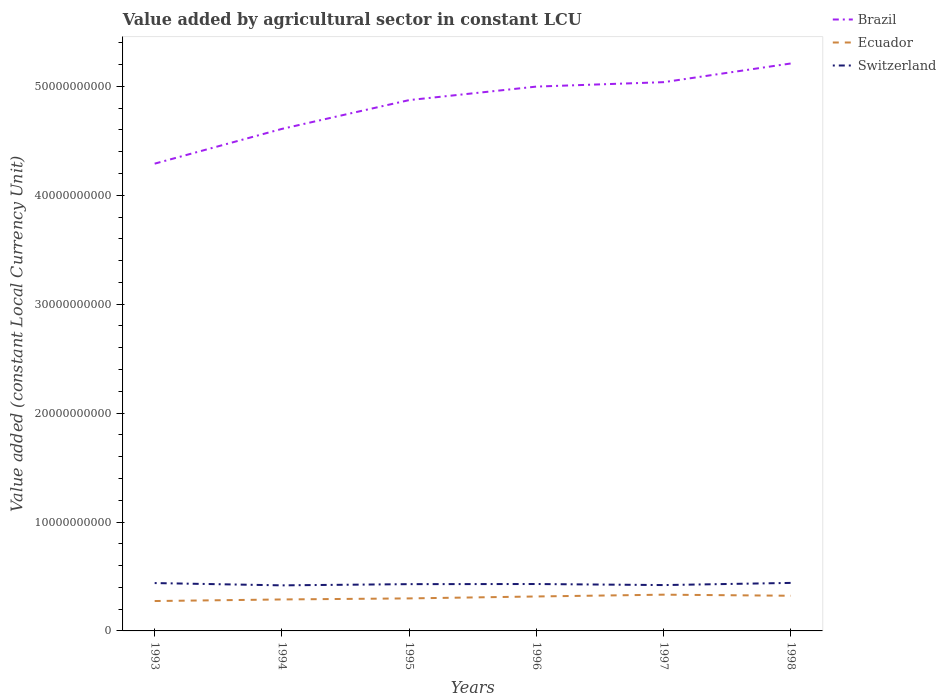How many different coloured lines are there?
Ensure brevity in your answer.  3. Across all years, what is the maximum value added by agricultural sector in Ecuador?
Provide a short and direct response. 2.74e+09. What is the total value added by agricultural sector in Brazil in the graph?
Your response must be concise. -4.06e+08. What is the difference between the highest and the second highest value added by agricultural sector in Ecuador?
Give a very brief answer. 5.84e+08. What is the difference between the highest and the lowest value added by agricultural sector in Brazil?
Offer a terse response. 4. How many years are there in the graph?
Your answer should be compact. 6. What is the difference between two consecutive major ticks on the Y-axis?
Keep it short and to the point. 1.00e+1. Are the values on the major ticks of Y-axis written in scientific E-notation?
Keep it short and to the point. No. Does the graph contain any zero values?
Ensure brevity in your answer.  No. Does the graph contain grids?
Give a very brief answer. No. Where does the legend appear in the graph?
Offer a terse response. Top right. What is the title of the graph?
Offer a terse response. Value added by agricultural sector in constant LCU. Does "Estonia" appear as one of the legend labels in the graph?
Your response must be concise. No. What is the label or title of the X-axis?
Your answer should be compact. Years. What is the label or title of the Y-axis?
Keep it short and to the point. Value added (constant Local Currency Unit). What is the Value added (constant Local Currency Unit) in Brazil in 1993?
Make the answer very short. 4.29e+1. What is the Value added (constant Local Currency Unit) of Ecuador in 1993?
Your response must be concise. 2.74e+09. What is the Value added (constant Local Currency Unit) in Switzerland in 1993?
Give a very brief answer. 4.39e+09. What is the Value added (constant Local Currency Unit) in Brazil in 1994?
Keep it short and to the point. 4.61e+1. What is the Value added (constant Local Currency Unit) of Ecuador in 1994?
Provide a succinct answer. 2.89e+09. What is the Value added (constant Local Currency Unit) in Switzerland in 1994?
Offer a very short reply. 4.18e+09. What is the Value added (constant Local Currency Unit) of Brazil in 1995?
Keep it short and to the point. 4.87e+1. What is the Value added (constant Local Currency Unit) of Ecuador in 1995?
Your answer should be very brief. 2.99e+09. What is the Value added (constant Local Currency Unit) in Switzerland in 1995?
Offer a very short reply. 4.29e+09. What is the Value added (constant Local Currency Unit) of Brazil in 1996?
Offer a very short reply. 5.00e+1. What is the Value added (constant Local Currency Unit) of Ecuador in 1996?
Keep it short and to the point. 3.16e+09. What is the Value added (constant Local Currency Unit) of Switzerland in 1996?
Provide a short and direct response. 4.31e+09. What is the Value added (constant Local Currency Unit) of Brazil in 1997?
Keep it short and to the point. 5.04e+1. What is the Value added (constant Local Currency Unit) of Ecuador in 1997?
Your answer should be very brief. 3.33e+09. What is the Value added (constant Local Currency Unit) of Switzerland in 1997?
Make the answer very short. 4.21e+09. What is the Value added (constant Local Currency Unit) of Brazil in 1998?
Your answer should be very brief. 5.21e+1. What is the Value added (constant Local Currency Unit) of Ecuador in 1998?
Offer a terse response. 3.23e+09. What is the Value added (constant Local Currency Unit) of Switzerland in 1998?
Offer a very short reply. 4.41e+09. Across all years, what is the maximum Value added (constant Local Currency Unit) of Brazil?
Offer a very short reply. 5.21e+1. Across all years, what is the maximum Value added (constant Local Currency Unit) in Ecuador?
Ensure brevity in your answer.  3.33e+09. Across all years, what is the maximum Value added (constant Local Currency Unit) of Switzerland?
Ensure brevity in your answer.  4.41e+09. Across all years, what is the minimum Value added (constant Local Currency Unit) in Brazil?
Keep it short and to the point. 4.29e+1. Across all years, what is the minimum Value added (constant Local Currency Unit) in Ecuador?
Your response must be concise. 2.74e+09. Across all years, what is the minimum Value added (constant Local Currency Unit) in Switzerland?
Your answer should be very brief. 4.18e+09. What is the total Value added (constant Local Currency Unit) in Brazil in the graph?
Provide a succinct answer. 2.90e+11. What is the total Value added (constant Local Currency Unit) in Ecuador in the graph?
Offer a very short reply. 1.83e+1. What is the total Value added (constant Local Currency Unit) in Switzerland in the graph?
Offer a very short reply. 2.58e+1. What is the difference between the Value added (constant Local Currency Unit) of Brazil in 1993 and that in 1994?
Offer a very short reply. -3.19e+09. What is the difference between the Value added (constant Local Currency Unit) of Ecuador in 1993 and that in 1994?
Give a very brief answer. -1.45e+08. What is the difference between the Value added (constant Local Currency Unit) of Switzerland in 1993 and that in 1994?
Make the answer very short. 2.11e+08. What is the difference between the Value added (constant Local Currency Unit) of Brazil in 1993 and that in 1995?
Provide a succinct answer. -5.84e+09. What is the difference between the Value added (constant Local Currency Unit) of Ecuador in 1993 and that in 1995?
Make the answer very short. -2.42e+08. What is the difference between the Value added (constant Local Currency Unit) in Switzerland in 1993 and that in 1995?
Provide a succinct answer. 9.94e+07. What is the difference between the Value added (constant Local Currency Unit) of Brazil in 1993 and that in 1996?
Provide a short and direct response. -7.08e+09. What is the difference between the Value added (constant Local Currency Unit) in Ecuador in 1993 and that in 1996?
Keep it short and to the point. -4.19e+08. What is the difference between the Value added (constant Local Currency Unit) of Switzerland in 1993 and that in 1996?
Provide a succinct answer. 8.82e+07. What is the difference between the Value added (constant Local Currency Unit) of Brazil in 1993 and that in 1997?
Offer a very short reply. -7.48e+09. What is the difference between the Value added (constant Local Currency Unit) in Ecuador in 1993 and that in 1997?
Offer a terse response. -5.84e+08. What is the difference between the Value added (constant Local Currency Unit) in Switzerland in 1993 and that in 1997?
Offer a very short reply. 1.85e+08. What is the difference between the Value added (constant Local Currency Unit) of Brazil in 1993 and that in 1998?
Your response must be concise. -9.20e+09. What is the difference between the Value added (constant Local Currency Unit) of Ecuador in 1993 and that in 1998?
Your answer should be compact. -4.85e+08. What is the difference between the Value added (constant Local Currency Unit) of Switzerland in 1993 and that in 1998?
Your answer should be very brief. -1.39e+07. What is the difference between the Value added (constant Local Currency Unit) of Brazil in 1994 and that in 1995?
Provide a short and direct response. -2.64e+09. What is the difference between the Value added (constant Local Currency Unit) of Ecuador in 1994 and that in 1995?
Make the answer very short. -9.67e+07. What is the difference between the Value added (constant Local Currency Unit) in Switzerland in 1994 and that in 1995?
Your response must be concise. -1.11e+08. What is the difference between the Value added (constant Local Currency Unit) of Brazil in 1994 and that in 1996?
Offer a very short reply. -3.88e+09. What is the difference between the Value added (constant Local Currency Unit) of Ecuador in 1994 and that in 1996?
Your response must be concise. -2.74e+08. What is the difference between the Value added (constant Local Currency Unit) in Switzerland in 1994 and that in 1996?
Offer a very short reply. -1.23e+08. What is the difference between the Value added (constant Local Currency Unit) of Brazil in 1994 and that in 1997?
Make the answer very short. -4.29e+09. What is the difference between the Value added (constant Local Currency Unit) in Ecuador in 1994 and that in 1997?
Keep it short and to the point. -4.39e+08. What is the difference between the Value added (constant Local Currency Unit) of Switzerland in 1994 and that in 1997?
Provide a succinct answer. -2.58e+07. What is the difference between the Value added (constant Local Currency Unit) in Brazil in 1994 and that in 1998?
Provide a short and direct response. -6.01e+09. What is the difference between the Value added (constant Local Currency Unit) of Ecuador in 1994 and that in 1998?
Provide a short and direct response. -3.40e+08. What is the difference between the Value added (constant Local Currency Unit) in Switzerland in 1994 and that in 1998?
Your answer should be very brief. -2.25e+08. What is the difference between the Value added (constant Local Currency Unit) of Brazil in 1995 and that in 1996?
Your response must be concise. -1.24e+09. What is the difference between the Value added (constant Local Currency Unit) in Ecuador in 1995 and that in 1996?
Provide a short and direct response. -1.77e+08. What is the difference between the Value added (constant Local Currency Unit) in Switzerland in 1995 and that in 1996?
Your response must be concise. -1.12e+07. What is the difference between the Value added (constant Local Currency Unit) of Brazil in 1995 and that in 1997?
Keep it short and to the point. -1.65e+09. What is the difference between the Value added (constant Local Currency Unit) in Ecuador in 1995 and that in 1997?
Provide a succinct answer. -3.42e+08. What is the difference between the Value added (constant Local Currency Unit) in Switzerland in 1995 and that in 1997?
Your answer should be compact. 8.56e+07. What is the difference between the Value added (constant Local Currency Unit) of Brazil in 1995 and that in 1998?
Offer a terse response. -3.36e+09. What is the difference between the Value added (constant Local Currency Unit) in Ecuador in 1995 and that in 1998?
Ensure brevity in your answer.  -2.43e+08. What is the difference between the Value added (constant Local Currency Unit) in Switzerland in 1995 and that in 1998?
Your answer should be very brief. -1.13e+08. What is the difference between the Value added (constant Local Currency Unit) in Brazil in 1996 and that in 1997?
Provide a succinct answer. -4.06e+08. What is the difference between the Value added (constant Local Currency Unit) in Ecuador in 1996 and that in 1997?
Offer a very short reply. -1.65e+08. What is the difference between the Value added (constant Local Currency Unit) of Switzerland in 1996 and that in 1997?
Your answer should be compact. 9.68e+07. What is the difference between the Value added (constant Local Currency Unit) of Brazil in 1996 and that in 1998?
Your response must be concise. -2.12e+09. What is the difference between the Value added (constant Local Currency Unit) in Ecuador in 1996 and that in 1998?
Provide a succinct answer. -6.60e+07. What is the difference between the Value added (constant Local Currency Unit) in Switzerland in 1996 and that in 1998?
Make the answer very short. -1.02e+08. What is the difference between the Value added (constant Local Currency Unit) in Brazil in 1997 and that in 1998?
Keep it short and to the point. -1.72e+09. What is the difference between the Value added (constant Local Currency Unit) in Ecuador in 1997 and that in 1998?
Your response must be concise. 9.92e+07. What is the difference between the Value added (constant Local Currency Unit) of Switzerland in 1997 and that in 1998?
Ensure brevity in your answer.  -1.99e+08. What is the difference between the Value added (constant Local Currency Unit) in Brazil in 1993 and the Value added (constant Local Currency Unit) in Ecuador in 1994?
Make the answer very short. 4.00e+1. What is the difference between the Value added (constant Local Currency Unit) in Brazil in 1993 and the Value added (constant Local Currency Unit) in Switzerland in 1994?
Your answer should be very brief. 3.87e+1. What is the difference between the Value added (constant Local Currency Unit) of Ecuador in 1993 and the Value added (constant Local Currency Unit) of Switzerland in 1994?
Give a very brief answer. -1.44e+09. What is the difference between the Value added (constant Local Currency Unit) in Brazil in 1993 and the Value added (constant Local Currency Unit) in Ecuador in 1995?
Provide a succinct answer. 3.99e+1. What is the difference between the Value added (constant Local Currency Unit) in Brazil in 1993 and the Value added (constant Local Currency Unit) in Switzerland in 1995?
Your answer should be very brief. 3.86e+1. What is the difference between the Value added (constant Local Currency Unit) of Ecuador in 1993 and the Value added (constant Local Currency Unit) of Switzerland in 1995?
Give a very brief answer. -1.55e+09. What is the difference between the Value added (constant Local Currency Unit) in Brazil in 1993 and the Value added (constant Local Currency Unit) in Ecuador in 1996?
Offer a terse response. 3.97e+1. What is the difference between the Value added (constant Local Currency Unit) of Brazil in 1993 and the Value added (constant Local Currency Unit) of Switzerland in 1996?
Your response must be concise. 3.86e+1. What is the difference between the Value added (constant Local Currency Unit) in Ecuador in 1993 and the Value added (constant Local Currency Unit) in Switzerland in 1996?
Your answer should be compact. -1.56e+09. What is the difference between the Value added (constant Local Currency Unit) in Brazil in 1993 and the Value added (constant Local Currency Unit) in Ecuador in 1997?
Offer a terse response. 3.96e+1. What is the difference between the Value added (constant Local Currency Unit) of Brazil in 1993 and the Value added (constant Local Currency Unit) of Switzerland in 1997?
Ensure brevity in your answer.  3.87e+1. What is the difference between the Value added (constant Local Currency Unit) of Ecuador in 1993 and the Value added (constant Local Currency Unit) of Switzerland in 1997?
Give a very brief answer. -1.47e+09. What is the difference between the Value added (constant Local Currency Unit) in Brazil in 1993 and the Value added (constant Local Currency Unit) in Ecuador in 1998?
Your response must be concise. 3.97e+1. What is the difference between the Value added (constant Local Currency Unit) in Brazil in 1993 and the Value added (constant Local Currency Unit) in Switzerland in 1998?
Your response must be concise. 3.85e+1. What is the difference between the Value added (constant Local Currency Unit) of Ecuador in 1993 and the Value added (constant Local Currency Unit) of Switzerland in 1998?
Offer a very short reply. -1.66e+09. What is the difference between the Value added (constant Local Currency Unit) in Brazil in 1994 and the Value added (constant Local Currency Unit) in Ecuador in 1995?
Keep it short and to the point. 4.31e+1. What is the difference between the Value added (constant Local Currency Unit) in Brazil in 1994 and the Value added (constant Local Currency Unit) in Switzerland in 1995?
Provide a short and direct response. 4.18e+1. What is the difference between the Value added (constant Local Currency Unit) in Ecuador in 1994 and the Value added (constant Local Currency Unit) in Switzerland in 1995?
Ensure brevity in your answer.  -1.41e+09. What is the difference between the Value added (constant Local Currency Unit) of Brazil in 1994 and the Value added (constant Local Currency Unit) of Ecuador in 1996?
Ensure brevity in your answer.  4.29e+1. What is the difference between the Value added (constant Local Currency Unit) of Brazil in 1994 and the Value added (constant Local Currency Unit) of Switzerland in 1996?
Make the answer very short. 4.18e+1. What is the difference between the Value added (constant Local Currency Unit) of Ecuador in 1994 and the Value added (constant Local Currency Unit) of Switzerland in 1996?
Your answer should be very brief. -1.42e+09. What is the difference between the Value added (constant Local Currency Unit) of Brazil in 1994 and the Value added (constant Local Currency Unit) of Ecuador in 1997?
Offer a terse response. 4.28e+1. What is the difference between the Value added (constant Local Currency Unit) in Brazil in 1994 and the Value added (constant Local Currency Unit) in Switzerland in 1997?
Your response must be concise. 4.19e+1. What is the difference between the Value added (constant Local Currency Unit) of Ecuador in 1994 and the Value added (constant Local Currency Unit) of Switzerland in 1997?
Make the answer very short. -1.32e+09. What is the difference between the Value added (constant Local Currency Unit) in Brazil in 1994 and the Value added (constant Local Currency Unit) in Ecuador in 1998?
Your answer should be very brief. 4.29e+1. What is the difference between the Value added (constant Local Currency Unit) of Brazil in 1994 and the Value added (constant Local Currency Unit) of Switzerland in 1998?
Your answer should be very brief. 4.17e+1. What is the difference between the Value added (constant Local Currency Unit) of Ecuador in 1994 and the Value added (constant Local Currency Unit) of Switzerland in 1998?
Your response must be concise. -1.52e+09. What is the difference between the Value added (constant Local Currency Unit) in Brazil in 1995 and the Value added (constant Local Currency Unit) in Ecuador in 1996?
Offer a very short reply. 4.56e+1. What is the difference between the Value added (constant Local Currency Unit) of Brazil in 1995 and the Value added (constant Local Currency Unit) of Switzerland in 1996?
Provide a succinct answer. 4.44e+1. What is the difference between the Value added (constant Local Currency Unit) in Ecuador in 1995 and the Value added (constant Local Currency Unit) in Switzerland in 1996?
Provide a short and direct response. -1.32e+09. What is the difference between the Value added (constant Local Currency Unit) in Brazil in 1995 and the Value added (constant Local Currency Unit) in Ecuador in 1997?
Provide a succinct answer. 4.54e+1. What is the difference between the Value added (constant Local Currency Unit) of Brazil in 1995 and the Value added (constant Local Currency Unit) of Switzerland in 1997?
Provide a succinct answer. 4.45e+1. What is the difference between the Value added (constant Local Currency Unit) of Ecuador in 1995 and the Value added (constant Local Currency Unit) of Switzerland in 1997?
Your answer should be compact. -1.22e+09. What is the difference between the Value added (constant Local Currency Unit) in Brazil in 1995 and the Value added (constant Local Currency Unit) in Ecuador in 1998?
Keep it short and to the point. 4.55e+1. What is the difference between the Value added (constant Local Currency Unit) in Brazil in 1995 and the Value added (constant Local Currency Unit) in Switzerland in 1998?
Give a very brief answer. 4.43e+1. What is the difference between the Value added (constant Local Currency Unit) in Ecuador in 1995 and the Value added (constant Local Currency Unit) in Switzerland in 1998?
Your answer should be compact. -1.42e+09. What is the difference between the Value added (constant Local Currency Unit) of Brazil in 1996 and the Value added (constant Local Currency Unit) of Ecuador in 1997?
Provide a short and direct response. 4.66e+1. What is the difference between the Value added (constant Local Currency Unit) of Brazil in 1996 and the Value added (constant Local Currency Unit) of Switzerland in 1997?
Make the answer very short. 4.58e+1. What is the difference between the Value added (constant Local Currency Unit) in Ecuador in 1996 and the Value added (constant Local Currency Unit) in Switzerland in 1997?
Provide a succinct answer. -1.05e+09. What is the difference between the Value added (constant Local Currency Unit) of Brazil in 1996 and the Value added (constant Local Currency Unit) of Ecuador in 1998?
Keep it short and to the point. 4.67e+1. What is the difference between the Value added (constant Local Currency Unit) of Brazil in 1996 and the Value added (constant Local Currency Unit) of Switzerland in 1998?
Make the answer very short. 4.56e+1. What is the difference between the Value added (constant Local Currency Unit) of Ecuador in 1996 and the Value added (constant Local Currency Unit) of Switzerland in 1998?
Ensure brevity in your answer.  -1.25e+09. What is the difference between the Value added (constant Local Currency Unit) in Brazil in 1997 and the Value added (constant Local Currency Unit) in Ecuador in 1998?
Offer a terse response. 4.72e+1. What is the difference between the Value added (constant Local Currency Unit) in Brazil in 1997 and the Value added (constant Local Currency Unit) in Switzerland in 1998?
Your response must be concise. 4.60e+1. What is the difference between the Value added (constant Local Currency Unit) of Ecuador in 1997 and the Value added (constant Local Currency Unit) of Switzerland in 1998?
Provide a short and direct response. -1.08e+09. What is the average Value added (constant Local Currency Unit) of Brazil per year?
Provide a succinct answer. 4.84e+1. What is the average Value added (constant Local Currency Unit) in Ecuador per year?
Ensure brevity in your answer.  3.06e+09. What is the average Value added (constant Local Currency Unit) of Switzerland per year?
Ensure brevity in your answer.  4.30e+09. In the year 1993, what is the difference between the Value added (constant Local Currency Unit) of Brazil and Value added (constant Local Currency Unit) of Ecuador?
Ensure brevity in your answer.  4.02e+1. In the year 1993, what is the difference between the Value added (constant Local Currency Unit) in Brazil and Value added (constant Local Currency Unit) in Switzerland?
Provide a succinct answer. 3.85e+1. In the year 1993, what is the difference between the Value added (constant Local Currency Unit) in Ecuador and Value added (constant Local Currency Unit) in Switzerland?
Your answer should be very brief. -1.65e+09. In the year 1994, what is the difference between the Value added (constant Local Currency Unit) of Brazil and Value added (constant Local Currency Unit) of Ecuador?
Your answer should be very brief. 4.32e+1. In the year 1994, what is the difference between the Value added (constant Local Currency Unit) in Brazil and Value added (constant Local Currency Unit) in Switzerland?
Offer a very short reply. 4.19e+1. In the year 1994, what is the difference between the Value added (constant Local Currency Unit) of Ecuador and Value added (constant Local Currency Unit) of Switzerland?
Your answer should be very brief. -1.29e+09. In the year 1995, what is the difference between the Value added (constant Local Currency Unit) in Brazil and Value added (constant Local Currency Unit) in Ecuador?
Your answer should be compact. 4.58e+1. In the year 1995, what is the difference between the Value added (constant Local Currency Unit) of Brazil and Value added (constant Local Currency Unit) of Switzerland?
Offer a very short reply. 4.44e+1. In the year 1995, what is the difference between the Value added (constant Local Currency Unit) of Ecuador and Value added (constant Local Currency Unit) of Switzerland?
Offer a very short reply. -1.31e+09. In the year 1996, what is the difference between the Value added (constant Local Currency Unit) of Brazil and Value added (constant Local Currency Unit) of Ecuador?
Make the answer very short. 4.68e+1. In the year 1996, what is the difference between the Value added (constant Local Currency Unit) in Brazil and Value added (constant Local Currency Unit) in Switzerland?
Keep it short and to the point. 4.57e+1. In the year 1996, what is the difference between the Value added (constant Local Currency Unit) in Ecuador and Value added (constant Local Currency Unit) in Switzerland?
Provide a succinct answer. -1.14e+09. In the year 1997, what is the difference between the Value added (constant Local Currency Unit) in Brazil and Value added (constant Local Currency Unit) in Ecuador?
Give a very brief answer. 4.71e+1. In the year 1997, what is the difference between the Value added (constant Local Currency Unit) in Brazil and Value added (constant Local Currency Unit) in Switzerland?
Give a very brief answer. 4.62e+1. In the year 1997, what is the difference between the Value added (constant Local Currency Unit) of Ecuador and Value added (constant Local Currency Unit) of Switzerland?
Provide a short and direct response. -8.81e+08. In the year 1998, what is the difference between the Value added (constant Local Currency Unit) in Brazil and Value added (constant Local Currency Unit) in Ecuador?
Offer a very short reply. 4.89e+1. In the year 1998, what is the difference between the Value added (constant Local Currency Unit) in Brazil and Value added (constant Local Currency Unit) in Switzerland?
Offer a very short reply. 4.77e+1. In the year 1998, what is the difference between the Value added (constant Local Currency Unit) in Ecuador and Value added (constant Local Currency Unit) in Switzerland?
Ensure brevity in your answer.  -1.18e+09. What is the ratio of the Value added (constant Local Currency Unit) in Brazil in 1993 to that in 1994?
Your answer should be very brief. 0.93. What is the ratio of the Value added (constant Local Currency Unit) in Ecuador in 1993 to that in 1994?
Offer a terse response. 0.95. What is the ratio of the Value added (constant Local Currency Unit) in Switzerland in 1993 to that in 1994?
Give a very brief answer. 1.05. What is the ratio of the Value added (constant Local Currency Unit) of Brazil in 1993 to that in 1995?
Make the answer very short. 0.88. What is the ratio of the Value added (constant Local Currency Unit) of Ecuador in 1993 to that in 1995?
Your answer should be very brief. 0.92. What is the ratio of the Value added (constant Local Currency Unit) in Switzerland in 1993 to that in 1995?
Offer a very short reply. 1.02. What is the ratio of the Value added (constant Local Currency Unit) of Brazil in 1993 to that in 1996?
Ensure brevity in your answer.  0.86. What is the ratio of the Value added (constant Local Currency Unit) in Ecuador in 1993 to that in 1996?
Offer a terse response. 0.87. What is the ratio of the Value added (constant Local Currency Unit) in Switzerland in 1993 to that in 1996?
Ensure brevity in your answer.  1.02. What is the ratio of the Value added (constant Local Currency Unit) of Brazil in 1993 to that in 1997?
Make the answer very short. 0.85. What is the ratio of the Value added (constant Local Currency Unit) in Ecuador in 1993 to that in 1997?
Make the answer very short. 0.82. What is the ratio of the Value added (constant Local Currency Unit) in Switzerland in 1993 to that in 1997?
Make the answer very short. 1.04. What is the ratio of the Value added (constant Local Currency Unit) in Brazil in 1993 to that in 1998?
Your response must be concise. 0.82. What is the ratio of the Value added (constant Local Currency Unit) in Ecuador in 1993 to that in 1998?
Ensure brevity in your answer.  0.85. What is the ratio of the Value added (constant Local Currency Unit) of Switzerland in 1993 to that in 1998?
Provide a succinct answer. 1. What is the ratio of the Value added (constant Local Currency Unit) of Brazil in 1994 to that in 1995?
Ensure brevity in your answer.  0.95. What is the ratio of the Value added (constant Local Currency Unit) in Ecuador in 1994 to that in 1995?
Offer a very short reply. 0.97. What is the ratio of the Value added (constant Local Currency Unit) in Switzerland in 1994 to that in 1995?
Your answer should be very brief. 0.97. What is the ratio of the Value added (constant Local Currency Unit) in Brazil in 1994 to that in 1996?
Offer a very short reply. 0.92. What is the ratio of the Value added (constant Local Currency Unit) of Ecuador in 1994 to that in 1996?
Your answer should be very brief. 0.91. What is the ratio of the Value added (constant Local Currency Unit) in Switzerland in 1994 to that in 1996?
Make the answer very short. 0.97. What is the ratio of the Value added (constant Local Currency Unit) in Brazil in 1994 to that in 1997?
Give a very brief answer. 0.91. What is the ratio of the Value added (constant Local Currency Unit) of Ecuador in 1994 to that in 1997?
Keep it short and to the point. 0.87. What is the ratio of the Value added (constant Local Currency Unit) in Switzerland in 1994 to that in 1997?
Keep it short and to the point. 0.99. What is the ratio of the Value added (constant Local Currency Unit) of Brazil in 1994 to that in 1998?
Your answer should be compact. 0.88. What is the ratio of the Value added (constant Local Currency Unit) of Ecuador in 1994 to that in 1998?
Offer a terse response. 0.89. What is the ratio of the Value added (constant Local Currency Unit) in Switzerland in 1994 to that in 1998?
Offer a very short reply. 0.95. What is the ratio of the Value added (constant Local Currency Unit) of Brazil in 1995 to that in 1996?
Offer a very short reply. 0.98. What is the ratio of the Value added (constant Local Currency Unit) of Ecuador in 1995 to that in 1996?
Provide a succinct answer. 0.94. What is the ratio of the Value added (constant Local Currency Unit) in Brazil in 1995 to that in 1997?
Your answer should be very brief. 0.97. What is the ratio of the Value added (constant Local Currency Unit) of Ecuador in 1995 to that in 1997?
Your answer should be compact. 0.9. What is the ratio of the Value added (constant Local Currency Unit) in Switzerland in 1995 to that in 1997?
Offer a terse response. 1.02. What is the ratio of the Value added (constant Local Currency Unit) in Brazil in 1995 to that in 1998?
Provide a succinct answer. 0.94. What is the ratio of the Value added (constant Local Currency Unit) of Ecuador in 1995 to that in 1998?
Ensure brevity in your answer.  0.92. What is the ratio of the Value added (constant Local Currency Unit) in Switzerland in 1995 to that in 1998?
Your answer should be compact. 0.97. What is the ratio of the Value added (constant Local Currency Unit) in Ecuador in 1996 to that in 1997?
Offer a very short reply. 0.95. What is the ratio of the Value added (constant Local Currency Unit) in Switzerland in 1996 to that in 1997?
Keep it short and to the point. 1.02. What is the ratio of the Value added (constant Local Currency Unit) in Brazil in 1996 to that in 1998?
Your answer should be very brief. 0.96. What is the ratio of the Value added (constant Local Currency Unit) in Ecuador in 1996 to that in 1998?
Your answer should be compact. 0.98. What is the ratio of the Value added (constant Local Currency Unit) in Switzerland in 1996 to that in 1998?
Provide a short and direct response. 0.98. What is the ratio of the Value added (constant Local Currency Unit) in Ecuador in 1997 to that in 1998?
Make the answer very short. 1.03. What is the ratio of the Value added (constant Local Currency Unit) of Switzerland in 1997 to that in 1998?
Ensure brevity in your answer.  0.95. What is the difference between the highest and the second highest Value added (constant Local Currency Unit) of Brazil?
Give a very brief answer. 1.72e+09. What is the difference between the highest and the second highest Value added (constant Local Currency Unit) of Ecuador?
Offer a very short reply. 9.92e+07. What is the difference between the highest and the second highest Value added (constant Local Currency Unit) of Switzerland?
Provide a short and direct response. 1.39e+07. What is the difference between the highest and the lowest Value added (constant Local Currency Unit) of Brazil?
Offer a very short reply. 9.20e+09. What is the difference between the highest and the lowest Value added (constant Local Currency Unit) of Ecuador?
Offer a very short reply. 5.84e+08. What is the difference between the highest and the lowest Value added (constant Local Currency Unit) of Switzerland?
Offer a terse response. 2.25e+08. 